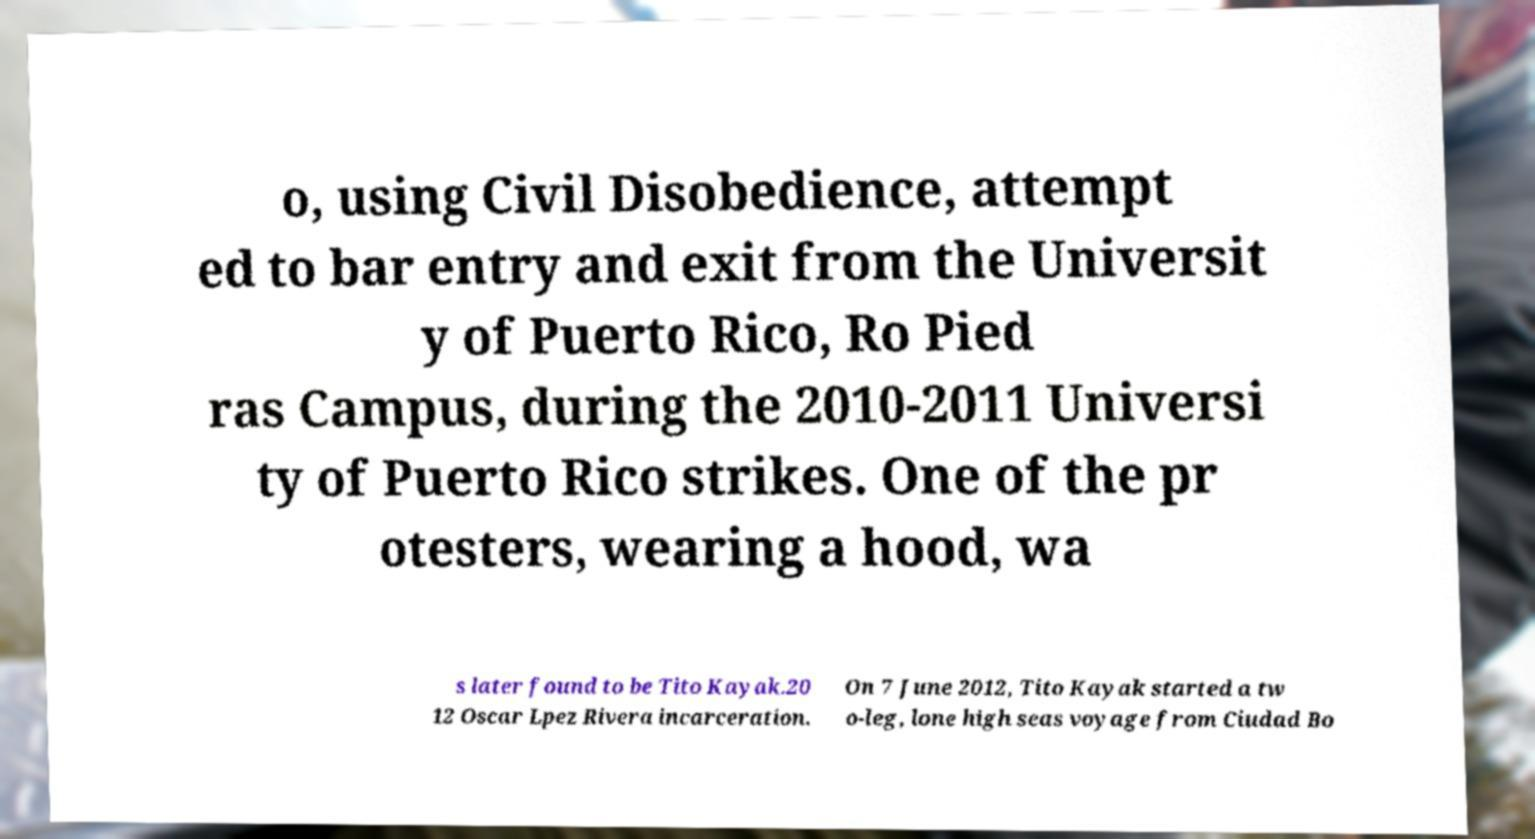Please read and relay the text visible in this image. What does it say? o, using Civil Disobedience, attempt ed to bar entry and exit from the Universit y of Puerto Rico, Ro Pied ras Campus, during the 2010-2011 Universi ty of Puerto Rico strikes. One of the pr otesters, wearing a hood, wa s later found to be Tito Kayak.20 12 Oscar Lpez Rivera incarceration. On 7 June 2012, Tito Kayak started a tw o-leg, lone high seas voyage from Ciudad Bo 